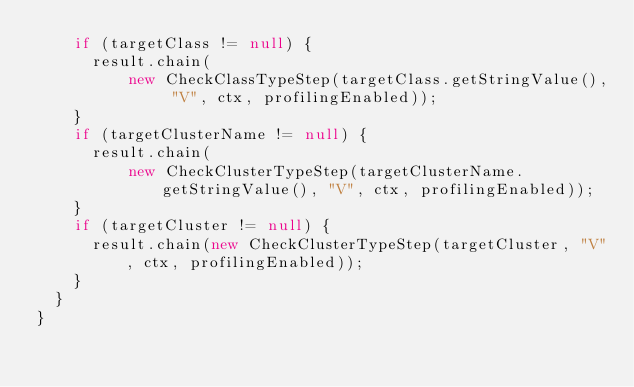Convert code to text. <code><loc_0><loc_0><loc_500><loc_500><_Java_>    if (targetClass != null) {
      result.chain(
          new CheckClassTypeStep(targetClass.getStringValue(), "V", ctx, profilingEnabled));
    }
    if (targetClusterName != null) {
      result.chain(
          new CheckClusterTypeStep(targetClusterName.getStringValue(), "V", ctx, profilingEnabled));
    }
    if (targetCluster != null) {
      result.chain(new CheckClusterTypeStep(targetCluster, "V", ctx, profilingEnabled));
    }
  }
}
</code> 